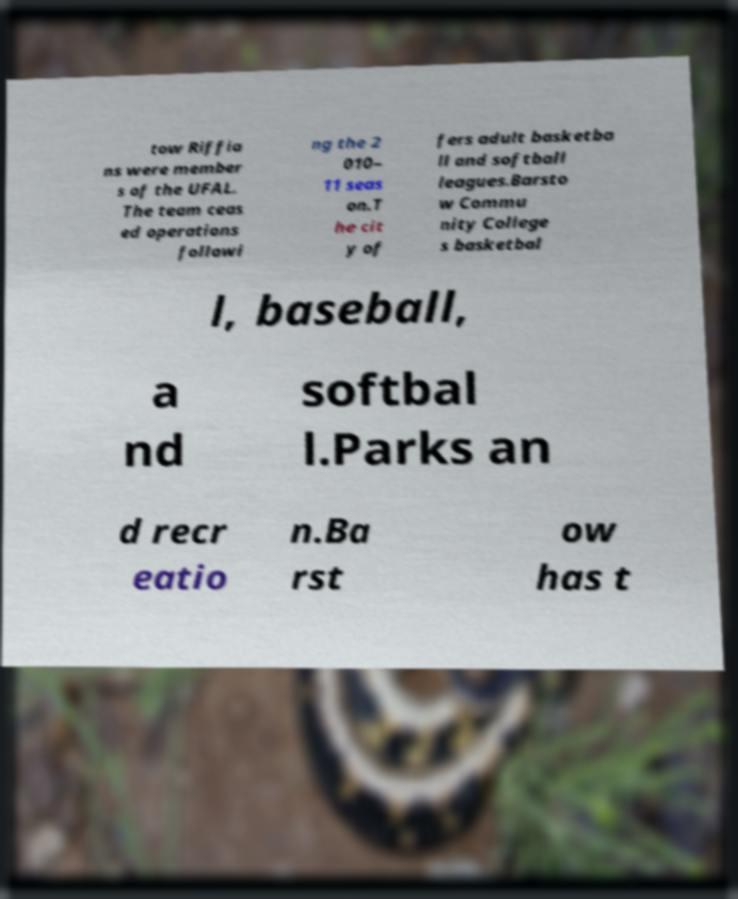Could you extract and type out the text from this image? tow Riffia ns were member s of the UFAL. The team ceas ed operations followi ng the 2 010– 11 seas on.T he cit y of fers adult basketba ll and softball leagues.Barsto w Commu nity College s basketbal l, baseball, a nd softbal l.Parks an d recr eatio n.Ba rst ow has t 